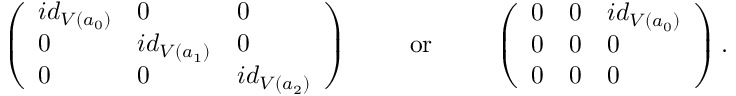<formula> <loc_0><loc_0><loc_500><loc_500>\left ( \begin{array} { l l l } { i d _ { V ( a _ { 0 } ) } } & { 0 } & { 0 } \\ { 0 } & { i d _ { V ( a _ { 1 } ) } } & { 0 } \\ { 0 } & { 0 } & { i d _ { V ( a _ { 2 } ) } } \end{array} \right ) \quad o r \quad \left ( \begin{array} { l l l } { 0 } & { 0 } & { i d _ { V ( a _ { 0 } ) } } \\ { 0 } & { 0 } & { 0 } \\ { 0 } & { 0 } & { 0 } \end{array} \right ) .</formula> 